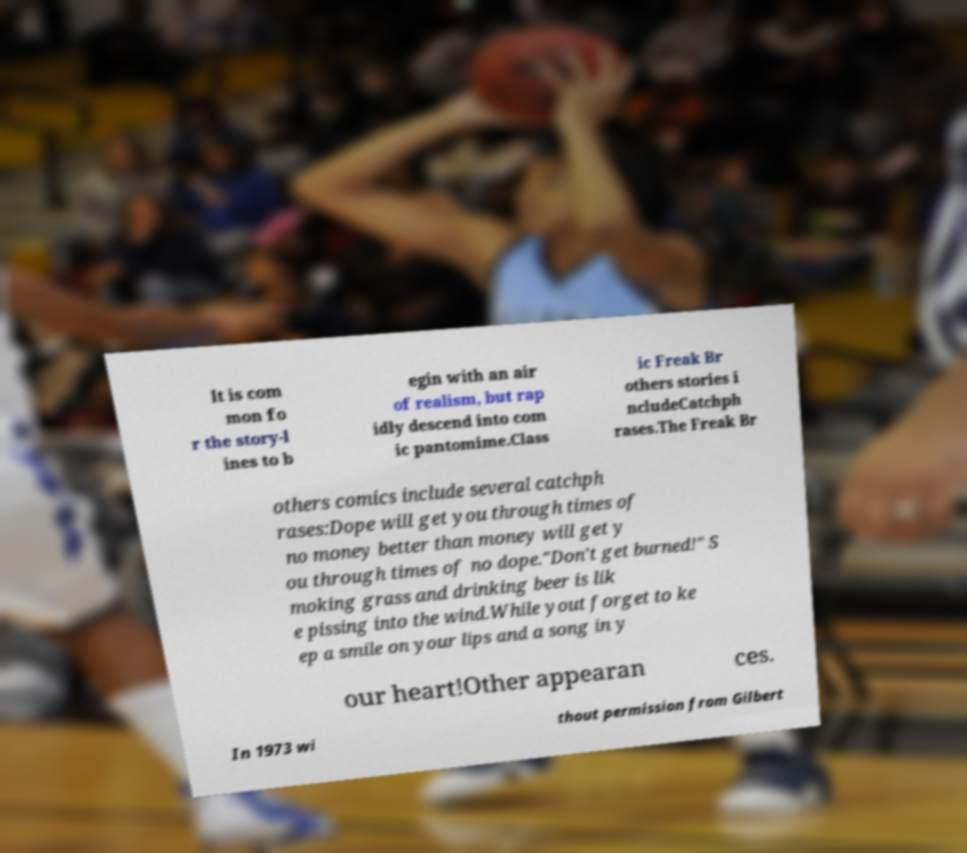Can you read and provide the text displayed in the image?This photo seems to have some interesting text. Can you extract and type it out for me? It is com mon fo r the story-l ines to b egin with an air of realism, but rap idly descend into com ic pantomime.Class ic Freak Br others stories i ncludeCatchph rases.The Freak Br others comics include several catchph rases:Dope will get you through times of no money better than money will get y ou through times of no dope."Don't get burned!" S moking grass and drinking beer is lik e pissing into the wind.While yout forget to ke ep a smile on your lips and a song in y our heart!Other appearan ces. In 1973 wi thout permission from Gilbert 